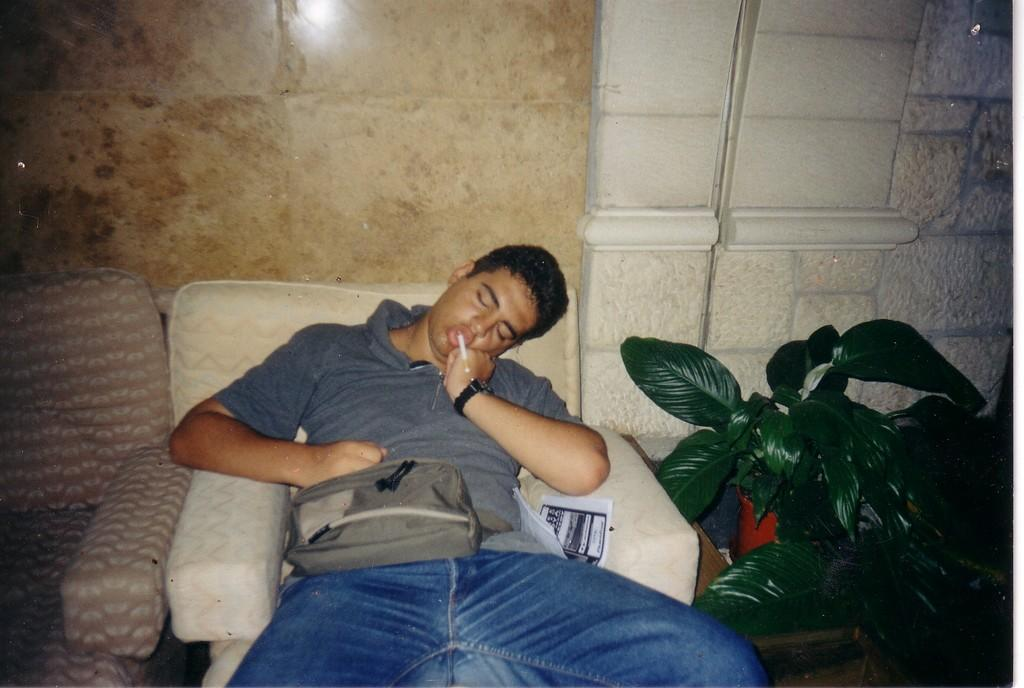Who is the main subject in the picture? There is a boy in the picture. What is the boy doing in the picture? The boy is sitting on a chair. What is the boy wearing in the picture? The boy is wearing a bag. What other object can be seen in the picture? There is a potted plant in the picture. What is visible in the background of the picture? There is a wall visible in the background of the picture. How many dolls are participating in the competition in the image? There are no dolls or competitions present in the image. What type of flesh can be seen on the boy's face in the image? There is no need to discuss the boy's flesh or any other body parts, as the focus is on the boy's actions and the objects around him. 